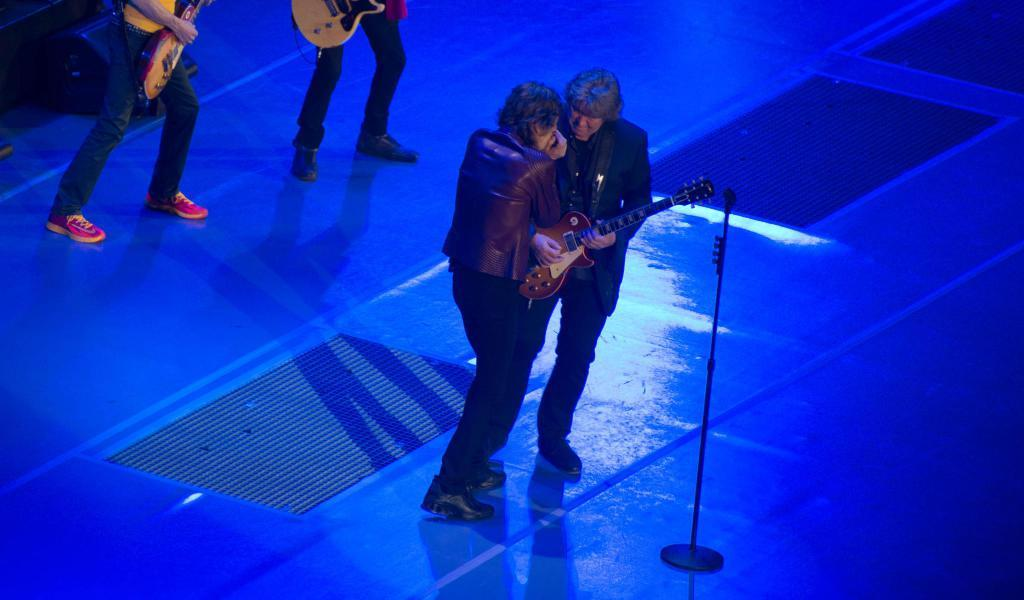How many people are visible in the foreground of the image? There are two people in the foreground of the image. What are the two people doing in the image? One person is singing, and the other person is playing a guitar. What type of quilt is being used as a prop by the scarecrow in the image? There is no scarecrow or quilt present in the image. How does the sun affect the performance of the two people in the image? The image does not provide information about the sun or its effect on the performance. 